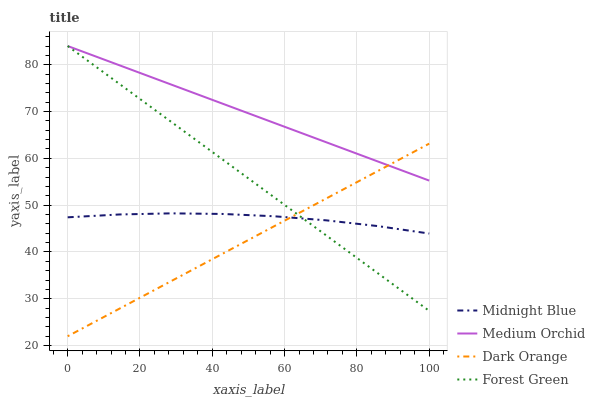Does Dark Orange have the minimum area under the curve?
Answer yes or no. Yes. Does Medium Orchid have the maximum area under the curve?
Answer yes or no. Yes. Does Forest Green have the minimum area under the curve?
Answer yes or no. No. Does Forest Green have the maximum area under the curve?
Answer yes or no. No. Is Dark Orange the smoothest?
Answer yes or no. Yes. Is Midnight Blue the roughest?
Answer yes or no. Yes. Is Forest Green the smoothest?
Answer yes or no. No. Is Forest Green the roughest?
Answer yes or no. No. Does Dark Orange have the lowest value?
Answer yes or no. Yes. Does Forest Green have the lowest value?
Answer yes or no. No. Does Medium Orchid have the highest value?
Answer yes or no. Yes. Does Midnight Blue have the highest value?
Answer yes or no. No. Is Midnight Blue less than Medium Orchid?
Answer yes or no. Yes. Is Medium Orchid greater than Midnight Blue?
Answer yes or no. Yes. Does Midnight Blue intersect Forest Green?
Answer yes or no. Yes. Is Midnight Blue less than Forest Green?
Answer yes or no. No. Is Midnight Blue greater than Forest Green?
Answer yes or no. No. Does Midnight Blue intersect Medium Orchid?
Answer yes or no. No. 